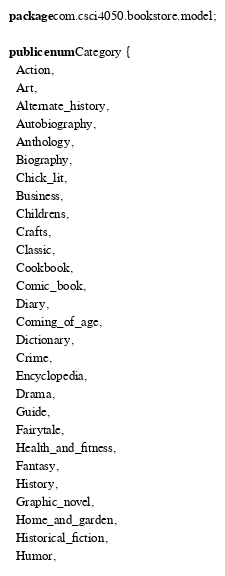Convert code to text. <code><loc_0><loc_0><loc_500><loc_500><_Java_>package com.csci4050.bookstore.model;

public enum Category {
  Action,
  Art,
  Alternate_history,
  Autobiography,
  Anthology,
  Biography,
  Chick_lit,
  Business,
  Childrens,
  Crafts,
  Classic,
  Cookbook,
  Comic_book,
  Diary,
  Coming_of_age,
  Dictionary,
  Crime,
  Encyclopedia,
  Drama,
  Guide,
  Fairytale,
  Health_and_fitness,
  Fantasy,
  History,
  Graphic_novel,
  Home_and_garden,
  Historical_fiction,
  Humor,</code> 